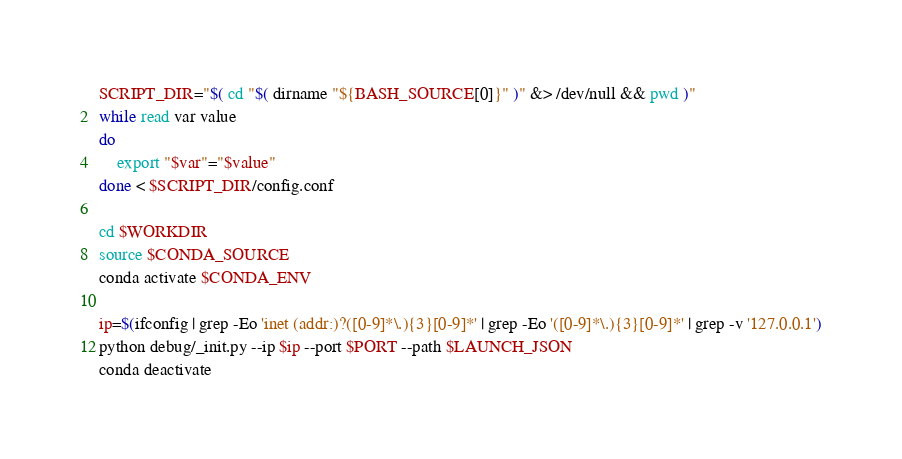<code> <loc_0><loc_0><loc_500><loc_500><_Bash_>
SCRIPT_DIR="$( cd "$( dirname "${BASH_SOURCE[0]}" )" &> /dev/null && pwd )"
while read var value
do
    export "$var"="$value"
done < $SCRIPT_DIR/config.conf

cd $WORKDIR
source $CONDA_SOURCE
conda activate $CONDA_ENV

ip=$(ifconfig | grep -Eo 'inet (addr:)?([0-9]*\.){3}[0-9]*' | grep -Eo '([0-9]*\.){3}[0-9]*' | grep -v '127.0.0.1')
python debug/_init.py --ip $ip --port $PORT --path $LAUNCH_JSON
conda deactivate</code> 